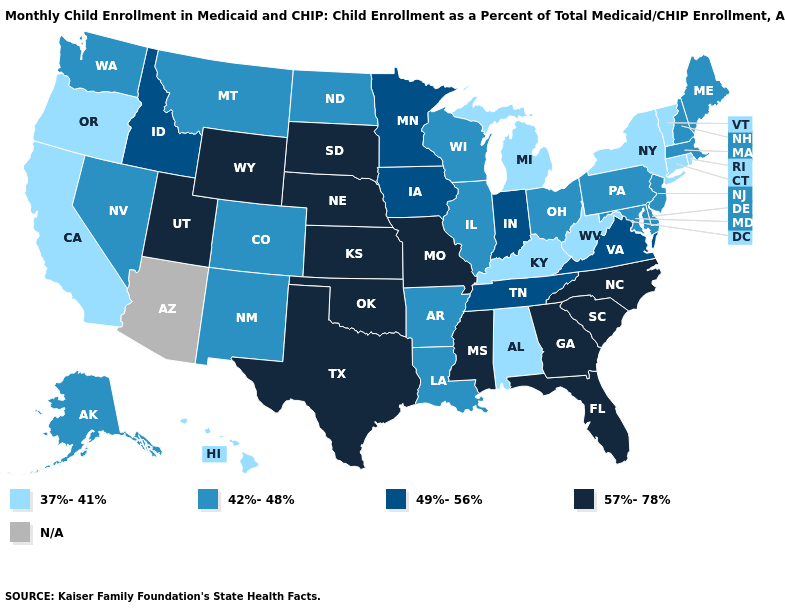Does Hawaii have the lowest value in the West?
Write a very short answer. Yes. Is the legend a continuous bar?
Write a very short answer. No. What is the value of Virginia?
Be succinct. 49%-56%. What is the value of New Hampshire?
Give a very brief answer. 42%-48%. Among the states that border Tennessee , which have the lowest value?
Short answer required. Alabama, Kentucky. What is the value of Iowa?
Be succinct. 49%-56%. Name the states that have a value in the range 42%-48%?
Keep it brief. Alaska, Arkansas, Colorado, Delaware, Illinois, Louisiana, Maine, Maryland, Massachusetts, Montana, Nevada, New Hampshire, New Jersey, New Mexico, North Dakota, Ohio, Pennsylvania, Washington, Wisconsin. Is the legend a continuous bar?
Concise answer only. No. Does the map have missing data?
Concise answer only. Yes. Does Rhode Island have the lowest value in the USA?
Concise answer only. Yes. Does Connecticut have the highest value in the Northeast?
Quick response, please. No. What is the value of Alaska?
Give a very brief answer. 42%-48%. What is the value of Wisconsin?
Short answer required. 42%-48%. What is the lowest value in the USA?
Give a very brief answer. 37%-41%. 